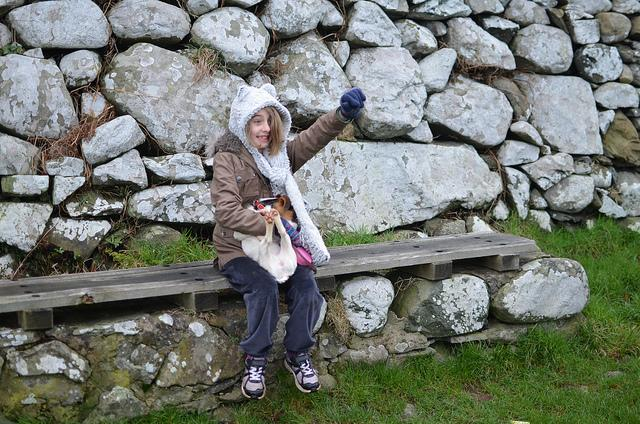What does the girl hold? Please explain your reasoning. dog. You can see his paws in the picture of him holding. 